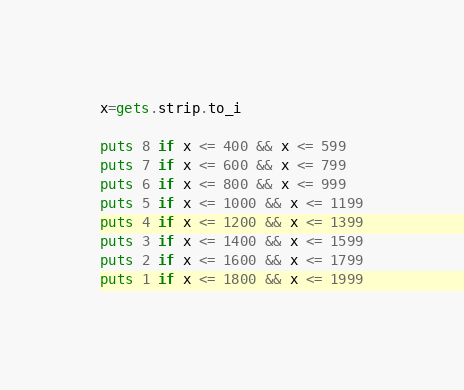<code> <loc_0><loc_0><loc_500><loc_500><_Ruby_>x=gets.strip.to_i

puts 8 if x <= 400 && x <= 599
puts 7 if x <= 600 && x <= 799
puts 6 if x <= 800 && x <= 999
puts 5 if x <= 1000 && x <= 1199
puts 4 if x <= 1200 && x <= 1399
puts 3 if x <= 1400 && x <= 1599
puts 2 if x <= 1600 && x <= 1799
puts 1 if x <= 1800 && x <= 1999
</code> 